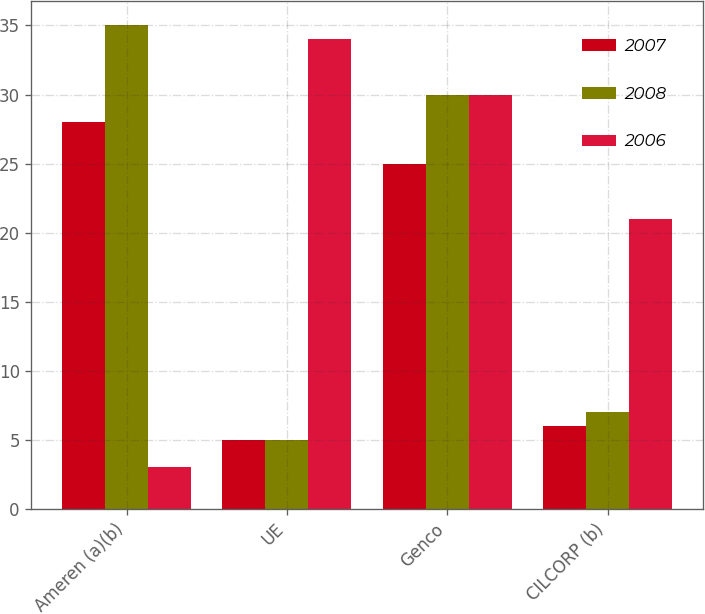<chart> <loc_0><loc_0><loc_500><loc_500><stacked_bar_chart><ecel><fcel>Ameren (a)(b)<fcel>UE<fcel>Genco<fcel>CILCORP (b)<nl><fcel>2007<fcel>28<fcel>5<fcel>25<fcel>6<nl><fcel>2008<fcel>35<fcel>5<fcel>30<fcel>7<nl><fcel>2006<fcel>3<fcel>34<fcel>30<fcel>21<nl></chart> 